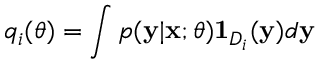Convert formula to latex. <formula><loc_0><loc_0><loc_500><loc_500>q _ { i } ( \theta ) = \int p ( y | x ; \theta ) 1 _ { D _ { i } } ( y ) d y</formula> 